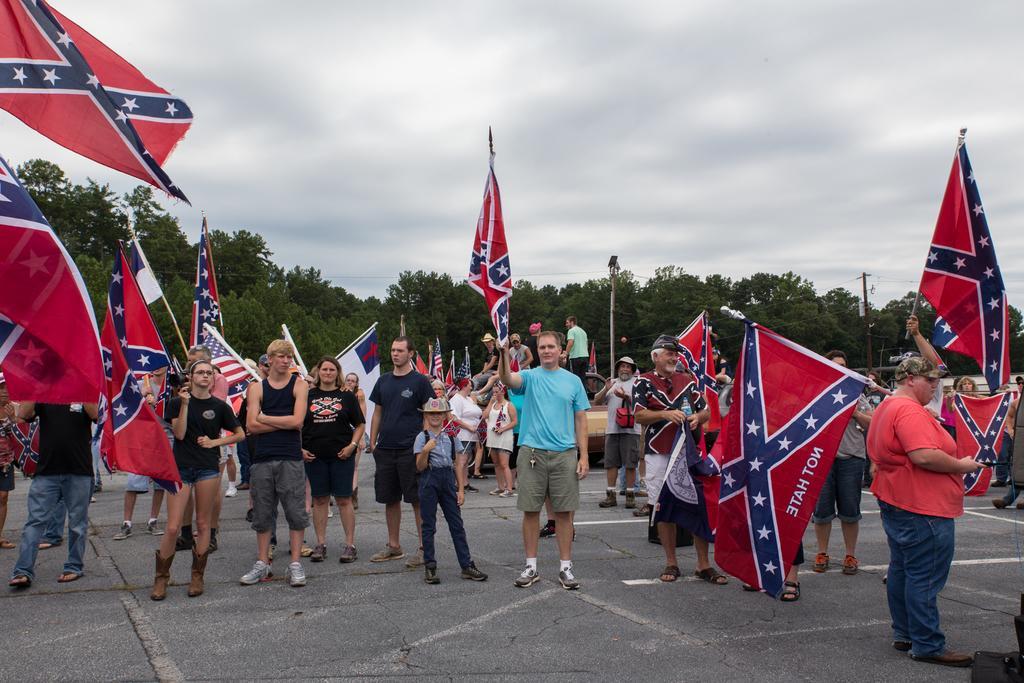Could you give a brief overview of what you see in this image? In this image I can see group of people standing and few are holding flags. They are in blue,red and white color. Back I can see trees,poles and wires. The sky is in blue and white color. 